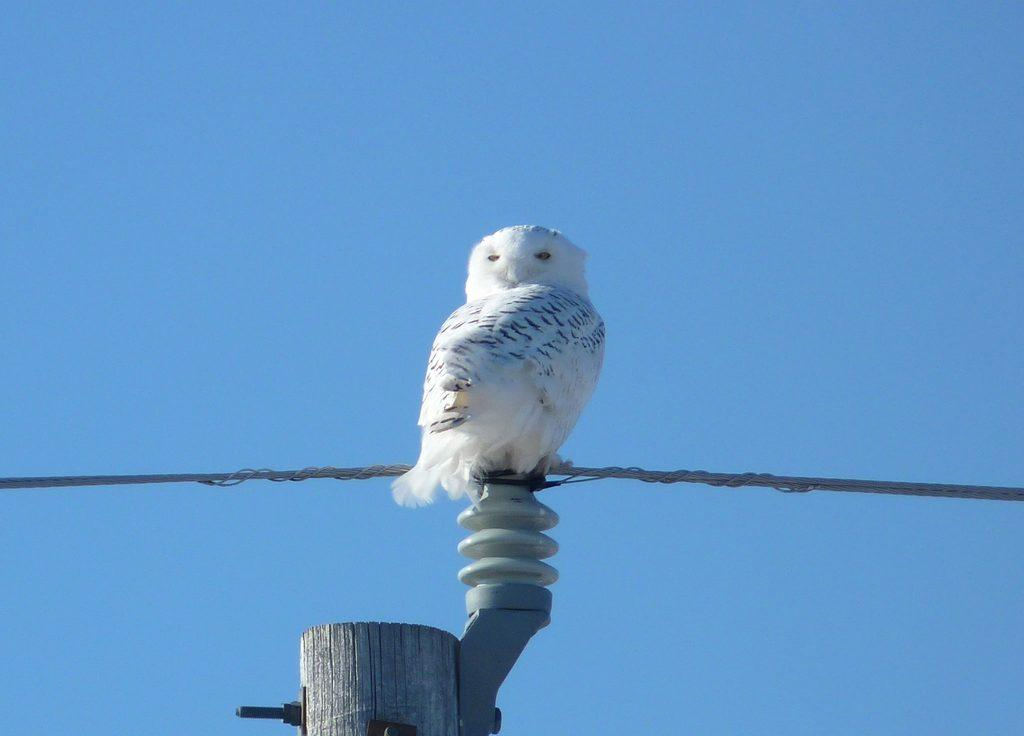What type of bird is in the image? There is a snowy owl in the image. Where is the owl perched? The owl is perched on a current pole. What else can be seen in the image besides the owl? There are wires visible in the image. What is the color of the sky in the background? The sky in the background is blue. What type of hospital is depicted in the image? There is no hospital present in the image; it features a snowy owl owl perched on a current pole with wires and a blue sky in the background. What is the cause of the hand's injury in the image? There is no hand or injury present in the image. 